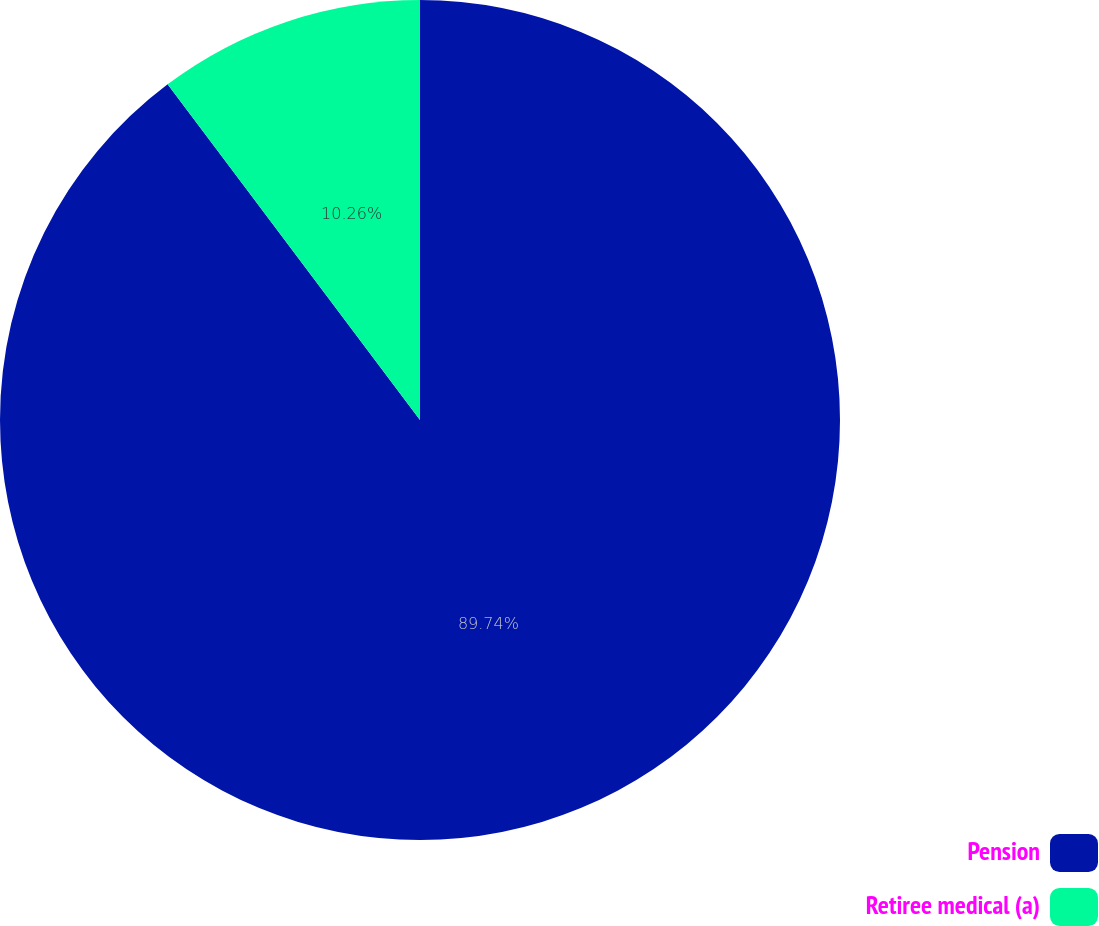Convert chart to OTSL. <chart><loc_0><loc_0><loc_500><loc_500><pie_chart><fcel>Pension<fcel>Retiree medical (a)<nl><fcel>89.74%<fcel>10.26%<nl></chart> 